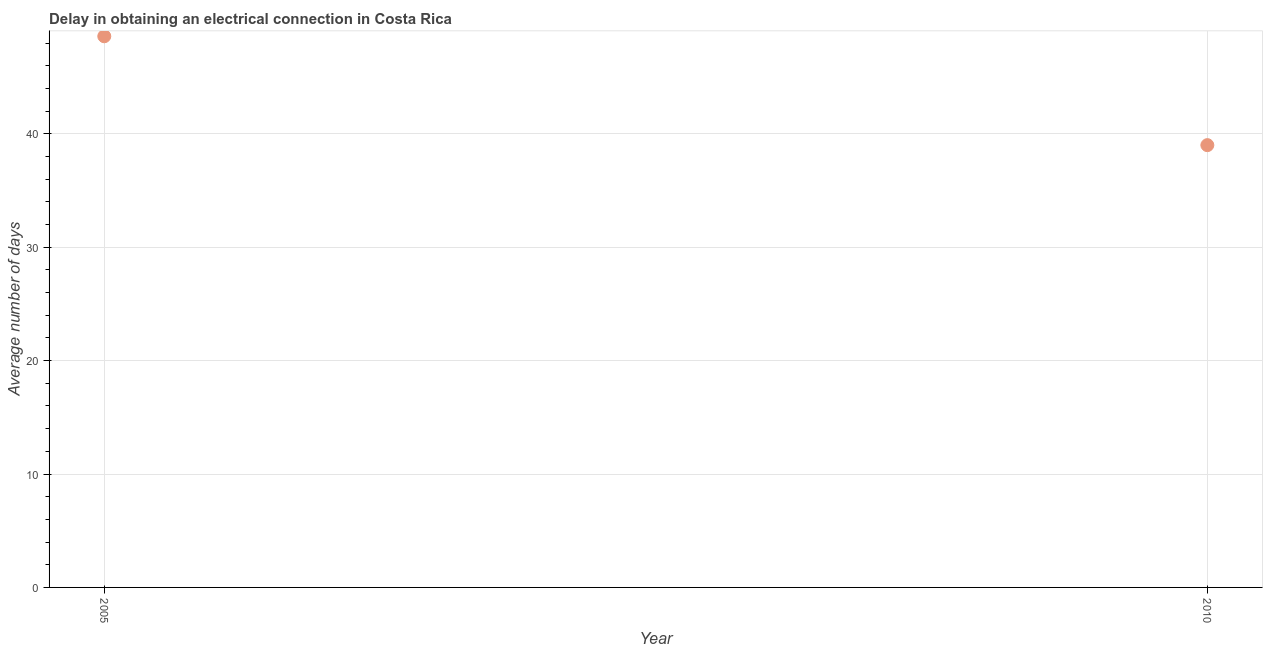What is the dalay in electrical connection in 2010?
Your answer should be compact. 39. Across all years, what is the maximum dalay in electrical connection?
Provide a short and direct response. 48.6. Across all years, what is the minimum dalay in electrical connection?
Your answer should be compact. 39. What is the sum of the dalay in electrical connection?
Provide a succinct answer. 87.6. What is the difference between the dalay in electrical connection in 2005 and 2010?
Your answer should be compact. 9.6. What is the average dalay in electrical connection per year?
Make the answer very short. 43.8. What is the median dalay in electrical connection?
Provide a succinct answer. 43.8. In how many years, is the dalay in electrical connection greater than 26 days?
Your response must be concise. 2. What is the ratio of the dalay in electrical connection in 2005 to that in 2010?
Make the answer very short. 1.25. In how many years, is the dalay in electrical connection greater than the average dalay in electrical connection taken over all years?
Give a very brief answer. 1. How many dotlines are there?
Your answer should be very brief. 1. Are the values on the major ticks of Y-axis written in scientific E-notation?
Your answer should be very brief. No. Does the graph contain any zero values?
Give a very brief answer. No. What is the title of the graph?
Keep it short and to the point. Delay in obtaining an electrical connection in Costa Rica. What is the label or title of the X-axis?
Ensure brevity in your answer.  Year. What is the label or title of the Y-axis?
Give a very brief answer. Average number of days. What is the Average number of days in 2005?
Make the answer very short. 48.6. What is the difference between the Average number of days in 2005 and 2010?
Your answer should be very brief. 9.6. What is the ratio of the Average number of days in 2005 to that in 2010?
Your response must be concise. 1.25. 